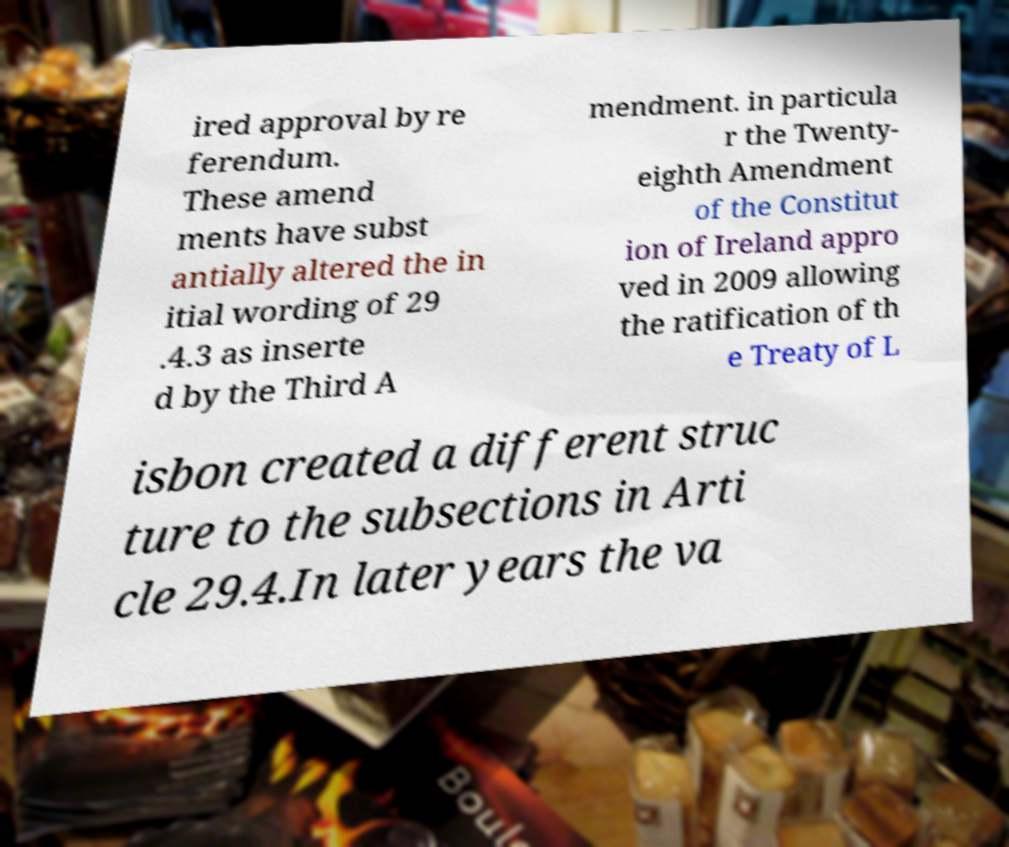Can you read and provide the text displayed in the image?This photo seems to have some interesting text. Can you extract and type it out for me? ired approval by re ferendum. These amend ments have subst antially altered the in itial wording of 29 .4.3 as inserte d by the Third A mendment. in particula r the Twenty- eighth Amendment of the Constitut ion of Ireland appro ved in 2009 allowing the ratification of th e Treaty of L isbon created a different struc ture to the subsections in Arti cle 29.4.In later years the va 